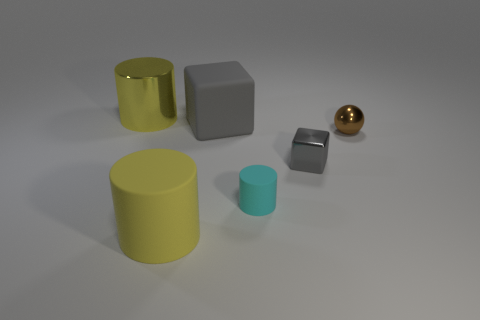Add 1 things. How many objects exist? 7 Subtract all cubes. How many objects are left? 4 Subtract 0 blue cubes. How many objects are left? 6 Subtract all gray rubber things. Subtract all cyan cylinders. How many objects are left? 4 Add 2 tiny cyan cylinders. How many tiny cyan cylinders are left? 3 Add 6 small metallic spheres. How many small metallic spheres exist? 7 